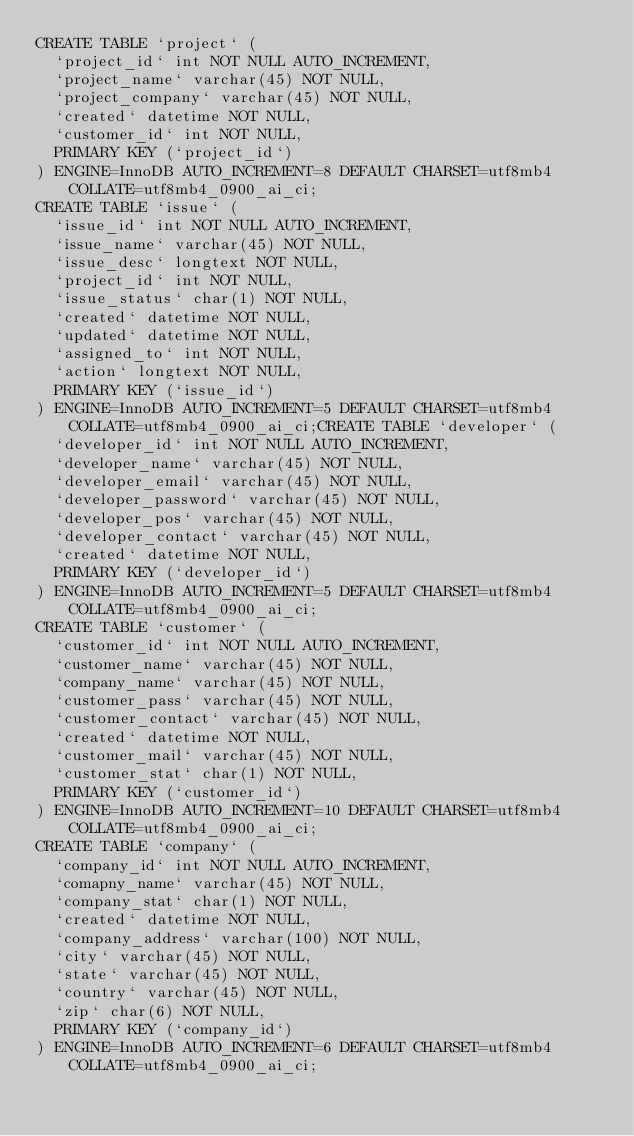<code> <loc_0><loc_0><loc_500><loc_500><_SQL_>CREATE TABLE `project` (
  `project_id` int NOT NULL AUTO_INCREMENT,
  `project_name` varchar(45) NOT NULL,
  `project_company` varchar(45) NOT NULL,
  `created` datetime NOT NULL,
  `customer_id` int NOT NULL,
  PRIMARY KEY (`project_id`)
) ENGINE=InnoDB AUTO_INCREMENT=8 DEFAULT CHARSET=utf8mb4 COLLATE=utf8mb4_0900_ai_ci;
CREATE TABLE `issue` (
  `issue_id` int NOT NULL AUTO_INCREMENT,
  `issue_name` varchar(45) NOT NULL,
  `issue_desc` longtext NOT NULL,
  `project_id` int NOT NULL,
  `issue_status` char(1) NOT NULL,
  `created` datetime NOT NULL,
  `updated` datetime NOT NULL,
  `assigned_to` int NOT NULL,
  `action` longtext NOT NULL,
  PRIMARY KEY (`issue_id`)
) ENGINE=InnoDB AUTO_INCREMENT=5 DEFAULT CHARSET=utf8mb4 COLLATE=utf8mb4_0900_ai_ci;CREATE TABLE `developer` (
  `developer_id` int NOT NULL AUTO_INCREMENT,
  `developer_name` varchar(45) NOT NULL,
  `developer_email` varchar(45) NOT NULL,
  `developer_password` varchar(45) NOT NULL,
  `developer_pos` varchar(45) NOT NULL,
  `developer_contact` varchar(45) NOT NULL,
  `created` datetime NOT NULL,
  PRIMARY KEY (`developer_id`)
) ENGINE=InnoDB AUTO_INCREMENT=5 DEFAULT CHARSET=utf8mb4 COLLATE=utf8mb4_0900_ai_ci;
CREATE TABLE `customer` (
  `customer_id` int NOT NULL AUTO_INCREMENT,
  `customer_name` varchar(45) NOT NULL,
  `company_name` varchar(45) NOT NULL,
  `customer_pass` varchar(45) NOT NULL,
  `customer_contact` varchar(45) NOT NULL,
  `created` datetime NOT NULL,
  `customer_mail` varchar(45) NOT NULL,
  `customer_stat` char(1) NOT NULL,
  PRIMARY KEY (`customer_id`)
) ENGINE=InnoDB AUTO_INCREMENT=10 DEFAULT CHARSET=utf8mb4 COLLATE=utf8mb4_0900_ai_ci;
CREATE TABLE `company` (
  `company_id` int NOT NULL AUTO_INCREMENT,
  `comapny_name` varchar(45) NOT NULL,
  `company_stat` char(1) NOT NULL,
  `created` datetime NOT NULL,
  `company_address` varchar(100) NOT NULL,
  `city` varchar(45) NOT NULL,
  `state` varchar(45) NOT NULL,
  `country` varchar(45) NOT NULL,
  `zip` char(6) NOT NULL,
  PRIMARY KEY (`company_id`)
) ENGINE=InnoDB AUTO_INCREMENT=6 DEFAULT CHARSET=utf8mb4 COLLATE=utf8mb4_0900_ai_ci;

</code> 